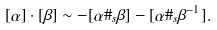<formula> <loc_0><loc_0><loc_500><loc_500>[ \alpha ] \cdot [ \beta ] \sim - [ \alpha \# _ { s } \beta ] - [ \alpha \# _ { s } \beta ^ { - 1 } ] .</formula> 